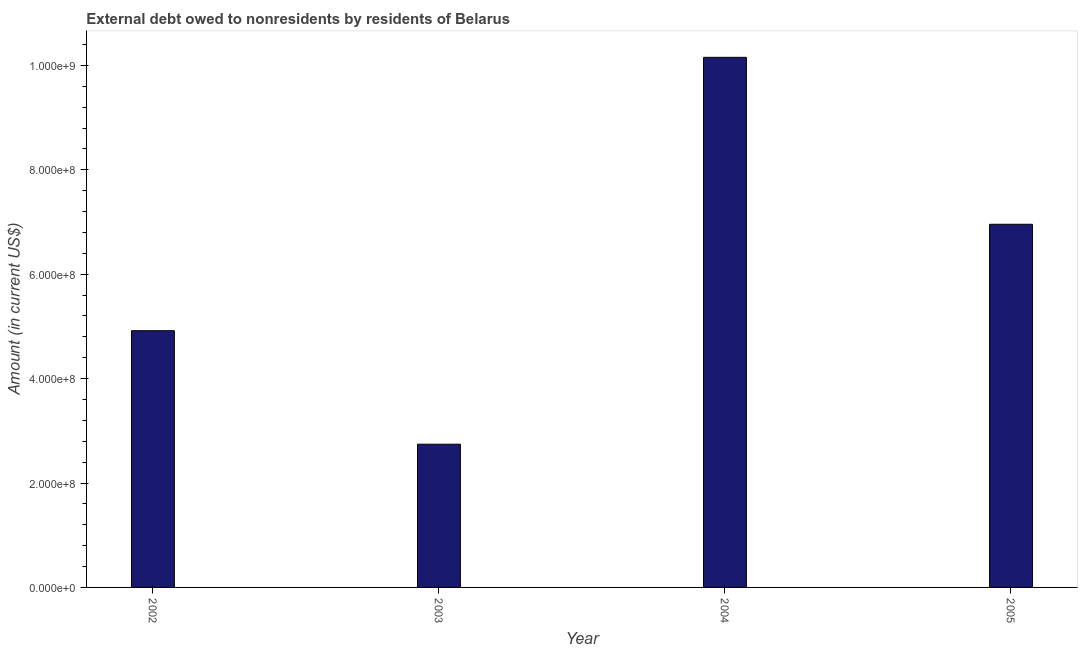What is the title of the graph?
Make the answer very short. External debt owed to nonresidents by residents of Belarus. What is the label or title of the X-axis?
Your response must be concise. Year. What is the label or title of the Y-axis?
Make the answer very short. Amount (in current US$). What is the debt in 2003?
Make the answer very short. 2.74e+08. Across all years, what is the maximum debt?
Offer a very short reply. 1.02e+09. Across all years, what is the minimum debt?
Offer a terse response. 2.74e+08. In which year was the debt maximum?
Offer a very short reply. 2004. In which year was the debt minimum?
Keep it short and to the point. 2003. What is the sum of the debt?
Provide a succinct answer. 2.48e+09. What is the difference between the debt in 2004 and 2005?
Provide a succinct answer. 3.20e+08. What is the average debt per year?
Provide a succinct answer. 6.19e+08. What is the median debt?
Your answer should be compact. 5.94e+08. In how many years, is the debt greater than 200000000 US$?
Your answer should be very brief. 4. Do a majority of the years between 2003 and 2004 (inclusive) have debt greater than 800000000 US$?
Keep it short and to the point. No. What is the ratio of the debt in 2003 to that in 2004?
Your response must be concise. 0.27. Is the debt in 2003 less than that in 2005?
Give a very brief answer. Yes. What is the difference between the highest and the second highest debt?
Make the answer very short. 3.20e+08. What is the difference between the highest and the lowest debt?
Keep it short and to the point. 7.41e+08. In how many years, is the debt greater than the average debt taken over all years?
Your answer should be very brief. 2. How many bars are there?
Ensure brevity in your answer.  4. Are all the bars in the graph horizontal?
Offer a very short reply. No. What is the difference between two consecutive major ticks on the Y-axis?
Your answer should be compact. 2.00e+08. Are the values on the major ticks of Y-axis written in scientific E-notation?
Offer a very short reply. Yes. What is the Amount (in current US$) of 2002?
Give a very brief answer. 4.92e+08. What is the Amount (in current US$) in 2003?
Provide a short and direct response. 2.74e+08. What is the Amount (in current US$) of 2004?
Your answer should be very brief. 1.02e+09. What is the Amount (in current US$) in 2005?
Offer a very short reply. 6.96e+08. What is the difference between the Amount (in current US$) in 2002 and 2003?
Make the answer very short. 2.17e+08. What is the difference between the Amount (in current US$) in 2002 and 2004?
Your answer should be compact. -5.24e+08. What is the difference between the Amount (in current US$) in 2002 and 2005?
Offer a terse response. -2.04e+08. What is the difference between the Amount (in current US$) in 2003 and 2004?
Your response must be concise. -7.41e+08. What is the difference between the Amount (in current US$) in 2003 and 2005?
Provide a succinct answer. -4.21e+08. What is the difference between the Amount (in current US$) in 2004 and 2005?
Give a very brief answer. 3.20e+08. What is the ratio of the Amount (in current US$) in 2002 to that in 2003?
Your answer should be compact. 1.79. What is the ratio of the Amount (in current US$) in 2002 to that in 2004?
Provide a succinct answer. 0.48. What is the ratio of the Amount (in current US$) in 2002 to that in 2005?
Your answer should be compact. 0.71. What is the ratio of the Amount (in current US$) in 2003 to that in 2004?
Make the answer very short. 0.27. What is the ratio of the Amount (in current US$) in 2003 to that in 2005?
Provide a succinct answer. 0.39. What is the ratio of the Amount (in current US$) in 2004 to that in 2005?
Keep it short and to the point. 1.46. 